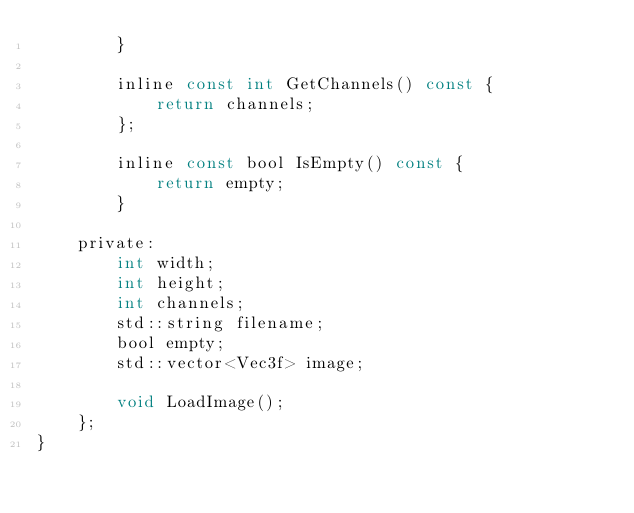Convert code to text. <code><loc_0><loc_0><loc_500><loc_500><_C_>        }

        inline const int GetChannels() const {
            return channels;
        };

        inline const bool IsEmpty() const {
            return empty;
        }

    private:
        int width;
        int height;
        int channels;
        std::string filename;
        bool empty;
        std::vector<Vec3f> image;

        void LoadImage();
    };
}</code> 